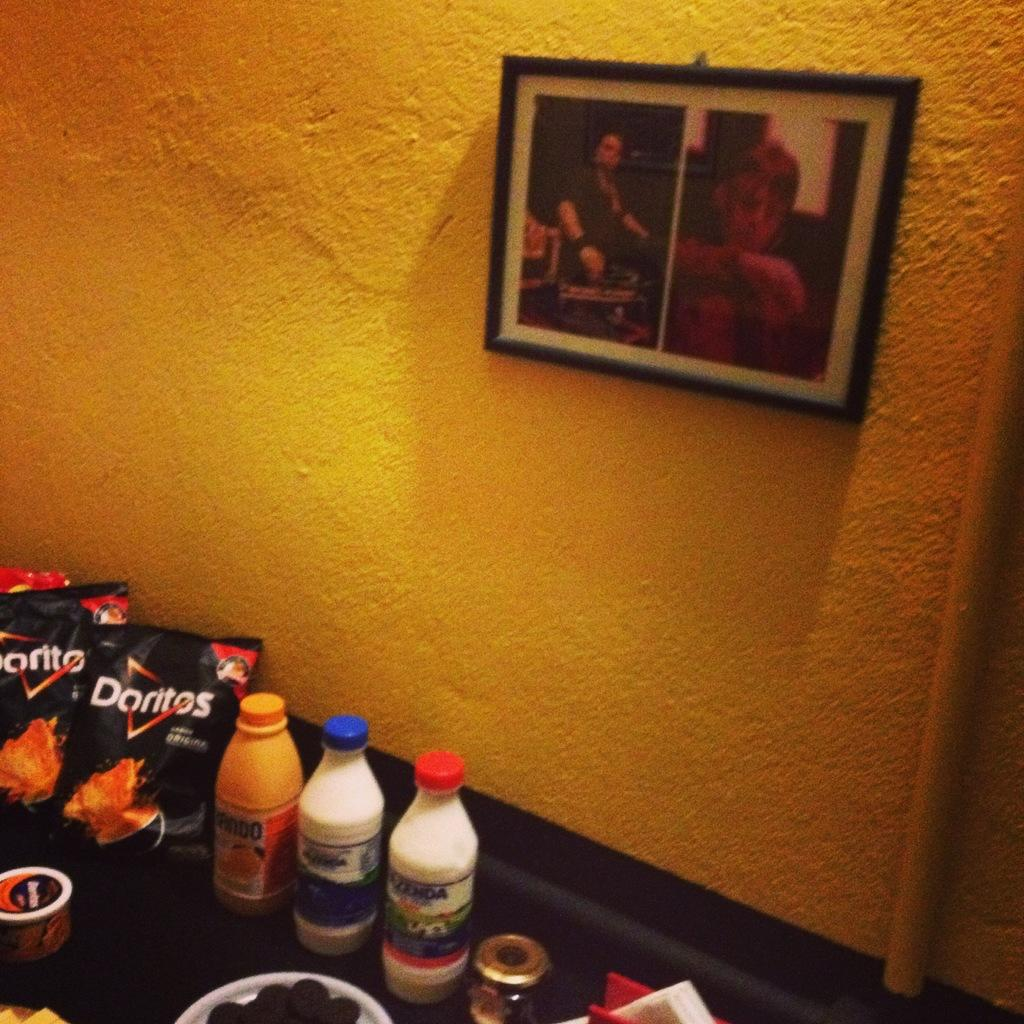<image>
Offer a succinct explanation of the picture presented. A table with Doritos and EZENDA brand milk sit next to a yellow wall 